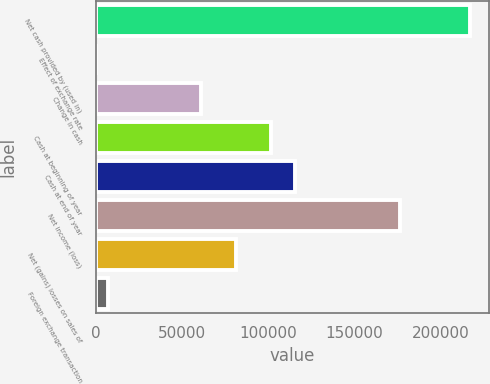<chart> <loc_0><loc_0><loc_500><loc_500><bar_chart><fcel>Net cash provided by (used in)<fcel>Effect of exchange rate<fcel>Change in cash<fcel>Cash at beginning of year<fcel>Cash at end of year<fcel>Net income (loss)<fcel>Net (gains) losses on sales of<fcel>Foreign exchange transaction<nl><fcel>216959<fcel>50<fcel>61055.6<fcel>101726<fcel>115283<fcel>176288<fcel>81390.8<fcel>6828.4<nl></chart> 